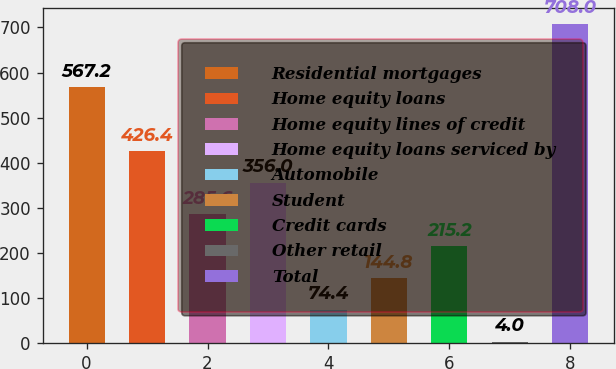Convert chart. <chart><loc_0><loc_0><loc_500><loc_500><bar_chart><fcel>Residential mortgages<fcel>Home equity loans<fcel>Home equity lines of credit<fcel>Home equity loans serviced by<fcel>Automobile<fcel>Student<fcel>Credit cards<fcel>Other retail<fcel>Total<nl><fcel>567.2<fcel>426.4<fcel>285.6<fcel>356<fcel>74.4<fcel>144.8<fcel>215.2<fcel>4<fcel>708<nl></chart> 